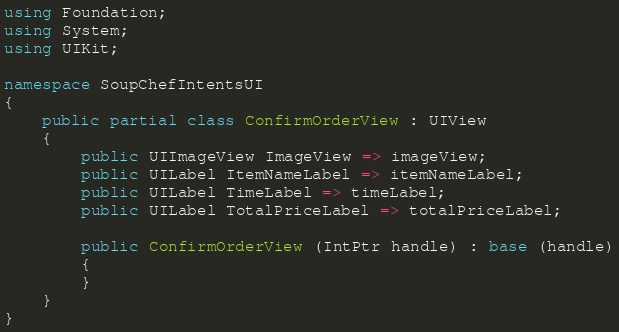<code> <loc_0><loc_0><loc_500><loc_500><_C#_>using Foundation;
using System;
using UIKit;

namespace SoupChefIntentsUI
{
    public partial class ConfirmOrderView : UIView
    {
        public UIImageView ImageView => imageView;
        public UILabel ItemNameLabel => itemNameLabel;
        public UILabel TimeLabel => timeLabel;
        public UILabel TotalPriceLabel => totalPriceLabel;

        public ConfirmOrderView (IntPtr handle) : base (handle)
        {
        }
    }
}</code> 